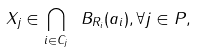Convert formula to latex. <formula><loc_0><loc_0><loc_500><loc_500>X _ { j } \in \bigcap _ { i \in C _ { j } } \ B _ { R _ { i } } ( a _ { i } ) , \forall j \in P ,</formula> 